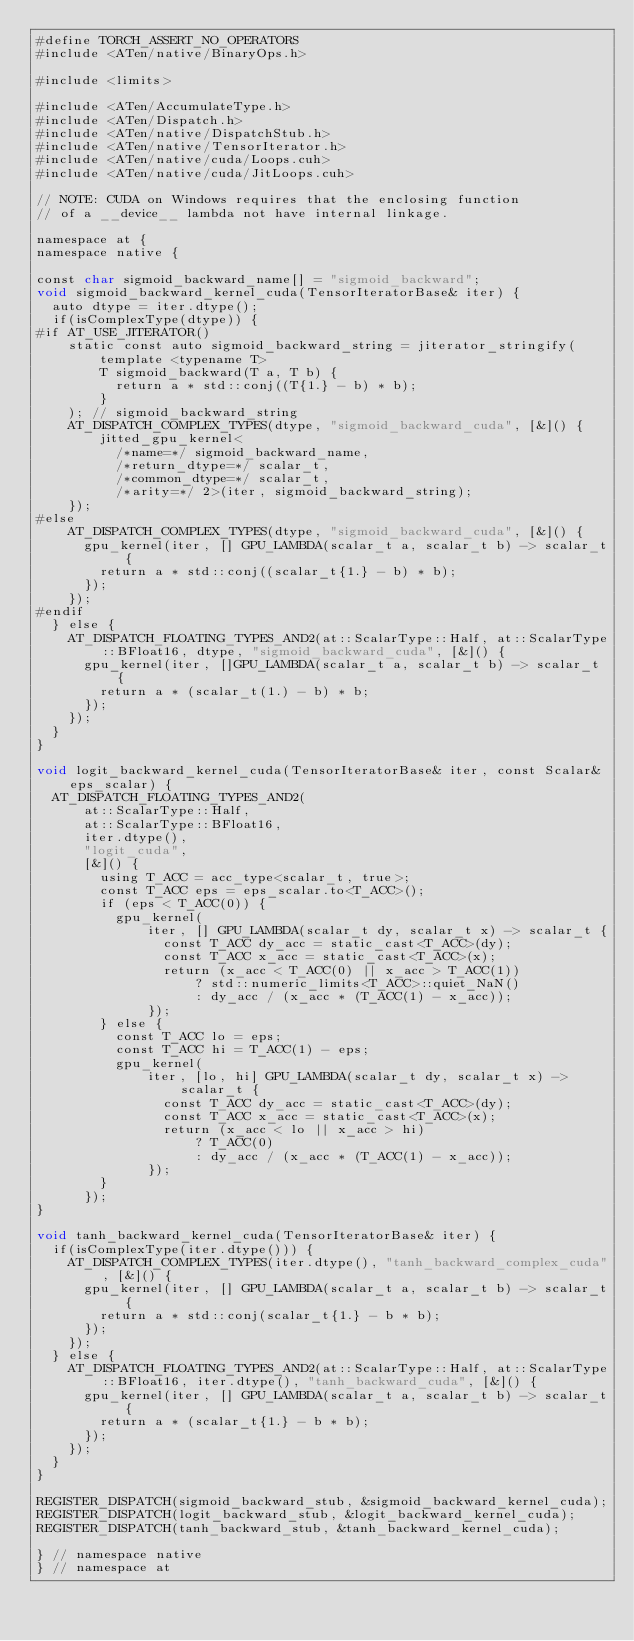<code> <loc_0><loc_0><loc_500><loc_500><_Cuda_>#define TORCH_ASSERT_NO_OPERATORS
#include <ATen/native/BinaryOps.h>

#include <limits>

#include <ATen/AccumulateType.h>
#include <ATen/Dispatch.h>
#include <ATen/native/DispatchStub.h>
#include <ATen/native/TensorIterator.h>
#include <ATen/native/cuda/Loops.cuh>
#include <ATen/native/cuda/JitLoops.cuh>

// NOTE: CUDA on Windows requires that the enclosing function
// of a __device__ lambda not have internal linkage.

namespace at {
namespace native {

const char sigmoid_backward_name[] = "sigmoid_backward";
void sigmoid_backward_kernel_cuda(TensorIteratorBase& iter) {
  auto dtype = iter.dtype();
  if(isComplexType(dtype)) {
#if AT_USE_JITERATOR()
    static const auto sigmoid_backward_string = jiterator_stringify(
        template <typename T>
        T sigmoid_backward(T a, T b) {
          return a * std::conj((T{1.} - b) * b);
        }
    ); // sigmoid_backward_string
    AT_DISPATCH_COMPLEX_TYPES(dtype, "sigmoid_backward_cuda", [&]() {
        jitted_gpu_kernel<
          /*name=*/ sigmoid_backward_name,
          /*return_dtype=*/ scalar_t,
          /*common_dtype=*/ scalar_t,
          /*arity=*/ 2>(iter, sigmoid_backward_string);
    });
#else
    AT_DISPATCH_COMPLEX_TYPES(dtype, "sigmoid_backward_cuda", [&]() {
      gpu_kernel(iter, [] GPU_LAMBDA(scalar_t a, scalar_t b) -> scalar_t {
        return a * std::conj((scalar_t{1.} - b) * b);
      });
    });
#endif
  } else {
    AT_DISPATCH_FLOATING_TYPES_AND2(at::ScalarType::Half, at::ScalarType::BFloat16, dtype, "sigmoid_backward_cuda", [&]() {
      gpu_kernel(iter, []GPU_LAMBDA(scalar_t a, scalar_t b) -> scalar_t {
        return a * (scalar_t(1.) - b) * b;
      });
    });
  }
}

void logit_backward_kernel_cuda(TensorIteratorBase& iter, const Scalar& eps_scalar) {
  AT_DISPATCH_FLOATING_TYPES_AND2(
      at::ScalarType::Half,
      at::ScalarType::BFloat16,
      iter.dtype(),
      "logit_cuda",
      [&]() {
        using T_ACC = acc_type<scalar_t, true>;
        const T_ACC eps = eps_scalar.to<T_ACC>();
        if (eps < T_ACC(0)) {
          gpu_kernel(
              iter, [] GPU_LAMBDA(scalar_t dy, scalar_t x) -> scalar_t {
                const T_ACC dy_acc = static_cast<T_ACC>(dy);
                const T_ACC x_acc = static_cast<T_ACC>(x);
                return (x_acc < T_ACC(0) || x_acc > T_ACC(1))
                    ? std::numeric_limits<T_ACC>::quiet_NaN()
                    : dy_acc / (x_acc * (T_ACC(1) - x_acc));
              });
        } else {
          const T_ACC lo = eps;
          const T_ACC hi = T_ACC(1) - eps;
          gpu_kernel(
              iter, [lo, hi] GPU_LAMBDA(scalar_t dy, scalar_t x) -> scalar_t {
                const T_ACC dy_acc = static_cast<T_ACC>(dy);
                const T_ACC x_acc = static_cast<T_ACC>(x);
                return (x_acc < lo || x_acc > hi)
                    ? T_ACC(0)
                    : dy_acc / (x_acc * (T_ACC(1) - x_acc));
              });
        }
      });
}

void tanh_backward_kernel_cuda(TensorIteratorBase& iter) {
  if(isComplexType(iter.dtype())) {
    AT_DISPATCH_COMPLEX_TYPES(iter.dtype(), "tanh_backward_complex_cuda", [&]() {
      gpu_kernel(iter, [] GPU_LAMBDA(scalar_t a, scalar_t b) -> scalar_t {
        return a * std::conj(scalar_t{1.} - b * b);
      });
    });
  } else {
    AT_DISPATCH_FLOATING_TYPES_AND2(at::ScalarType::Half, at::ScalarType::BFloat16, iter.dtype(), "tanh_backward_cuda", [&]() {
      gpu_kernel(iter, [] GPU_LAMBDA(scalar_t a, scalar_t b) -> scalar_t {
        return a * (scalar_t{1.} - b * b);
      });
    });
  }
}

REGISTER_DISPATCH(sigmoid_backward_stub, &sigmoid_backward_kernel_cuda);
REGISTER_DISPATCH(logit_backward_stub, &logit_backward_kernel_cuda);
REGISTER_DISPATCH(tanh_backward_stub, &tanh_backward_kernel_cuda);

} // namespace native
} // namespace at
</code> 